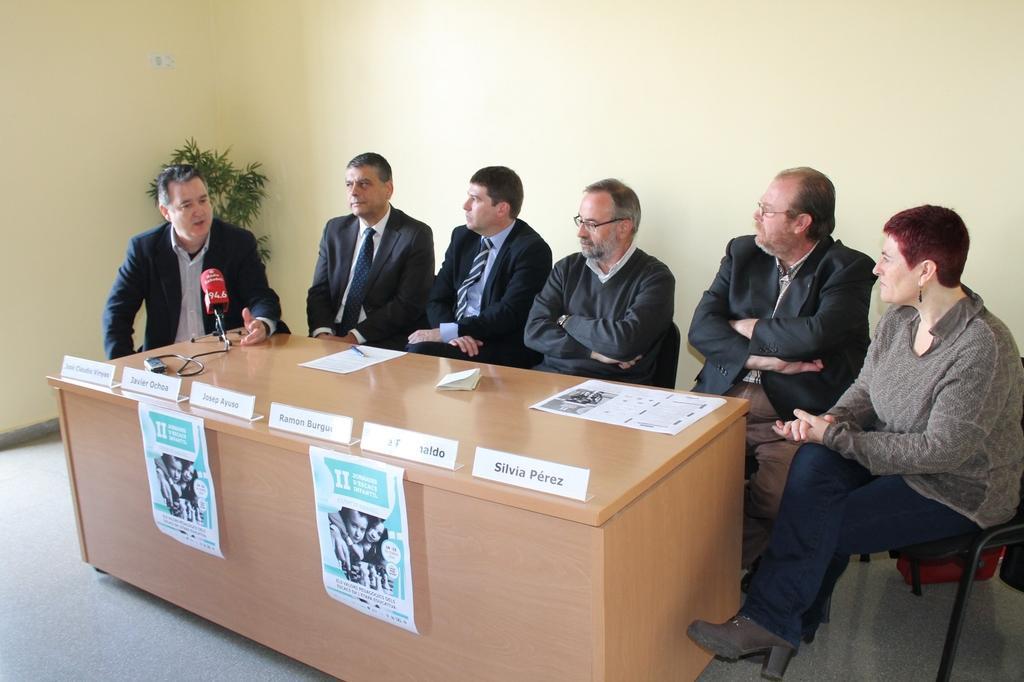How would you summarize this image in a sentence or two? The picture is a meeting hall where six people are seated. In the center of the image there is a desk with name plates on them and posters. On the left end on the table there is a microphone. A man in blue suit is talking, on the left side the other five people in the room are listening. On the right side of the image there is a woman wearing a gray color dress. In the background on the left side there is a houseplant. On the right side corner we can see the chair. 